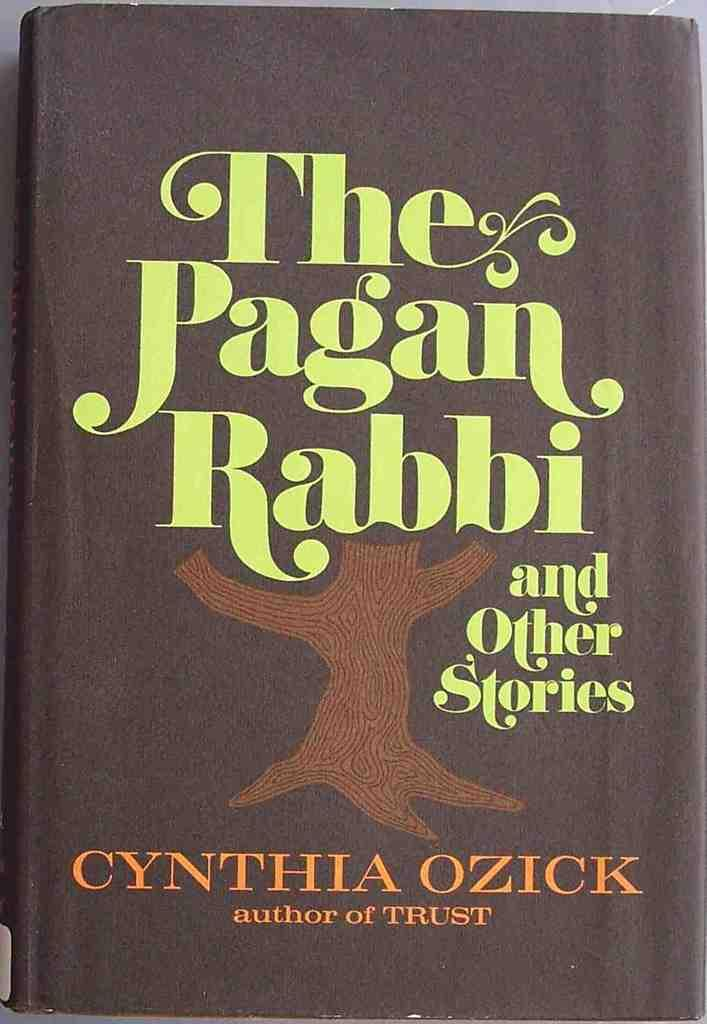<image>
Provide a brief description of the given image. A book by Cynthia Ozick is about a pagan rabbi. 